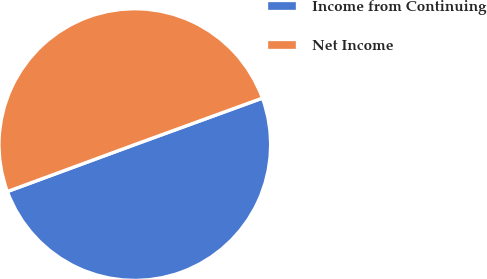Convert chart to OTSL. <chart><loc_0><loc_0><loc_500><loc_500><pie_chart><fcel>Income from Continuing<fcel>Net Income<nl><fcel>49.94%<fcel>50.06%<nl></chart> 